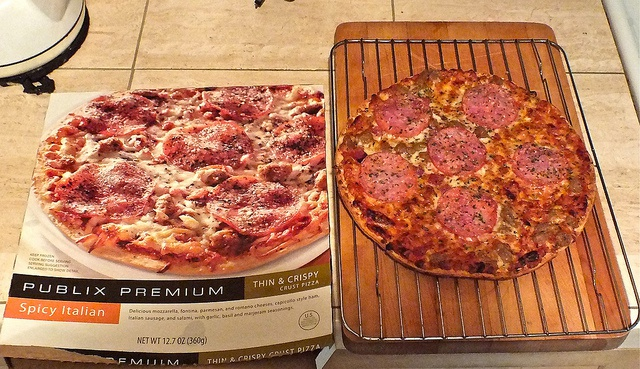Describe the objects in this image and their specific colors. I can see pizza in ivory, salmon, brown, and tan tones, pizza in ivory, brown, salmon, and red tones, book in ivory, black, and tan tones, and chair in ivory, beige, tan, and black tones in this image. 